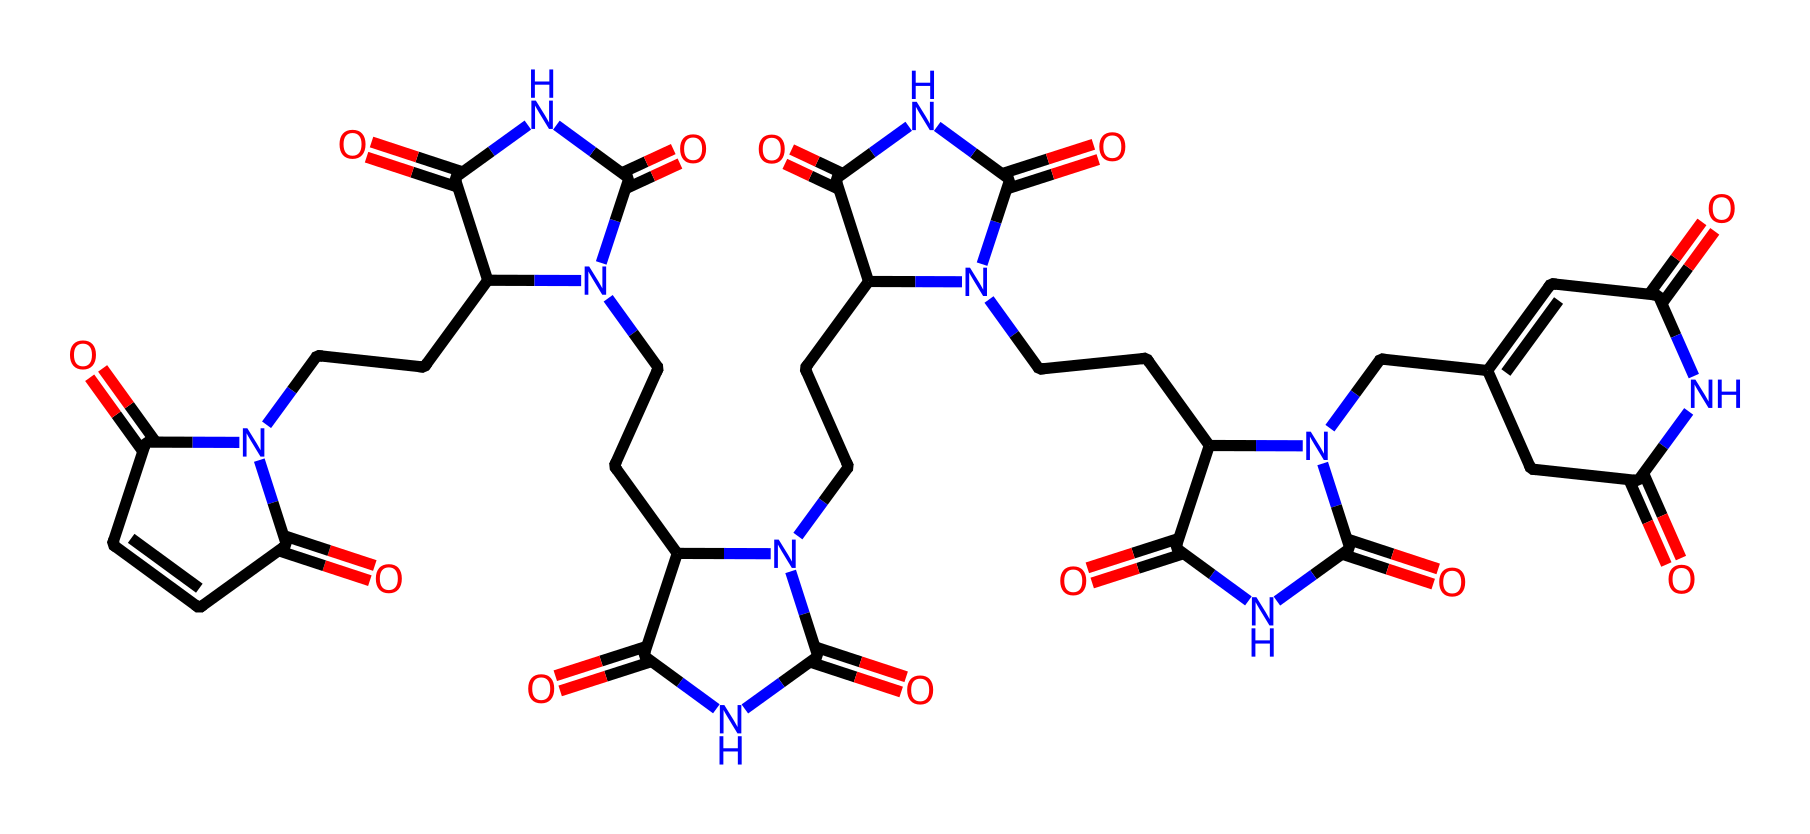What is the molecular formula of bismaleimide? To find the molecular formula, count the number of carbon (C), hydrogen (H), nitrogen (N), and oxygen (O) atoms in the SMILES representation. The total count shows 38 carbons, 47 hydrogens, 10 nitrogens, and 6 oxygens. Thus, the molecular formula is C38H47N10O6.
Answer: C38H47N10O6 How many nitrogen atoms are present in the structure? By scanning the SMILES code, you can identify each nitrogen (N) atom in the structure. There are ten occurrences of nitrogen, which can be confirmed by counting them in the representation.
Answer: 10 What is the functional group characteristic of imides present in this structure? Imides are characterized by the presence of a carbonyl group (C=O) directly attached to a nitrogen atom (N). Observing the SMILES, there are multiple carbonyl groups adjacent to nitrogen atoms confirming the imide functionality.
Answer: carbonyl and nitrogen How many rings are observable in the molecular structure? By examining the SMILES representation, you can identify any cycles (rings) in the structure, denoted by the numbers. The notation shows the formation of four distinct cyclic structures in the compound.
Answer: 4 What type of bonding predominantly exists in bismaleimide resins? The SMILES reveals a composition rich in carbon-nitrogen and carbon-oxygen bonds, specifically due to the various functional groups and linkages, emphasizing the presence of covalent bonds typical in bismaleimide resins.
Answer: covalent What is the significance of the carbonyl groups in bismaleimide? Carbonyl groups in bismaleimide structures typically increase thermal stability and rigidity, essential for high-frequency PCB applications. Their presence indicates potential for crosslinking and enhanced mechanical properties.
Answer: thermal stability and rigidity 